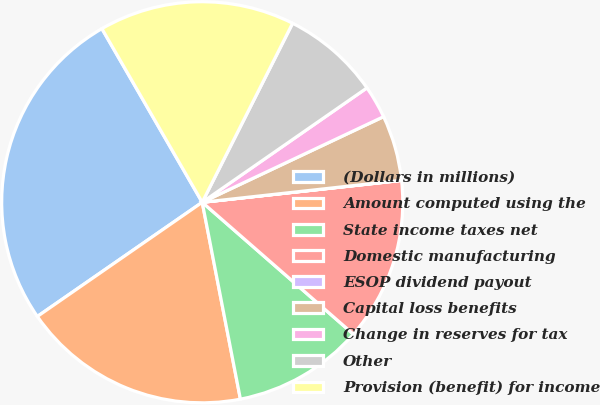Convert chart to OTSL. <chart><loc_0><loc_0><loc_500><loc_500><pie_chart><fcel>(Dollars in millions)<fcel>Amount computed using the<fcel>State income taxes net<fcel>Domestic manufacturing<fcel>ESOP dividend payout<fcel>Capital loss benefits<fcel>Change in reserves for tax<fcel>Other<fcel>Provision (benefit) for income<nl><fcel>26.3%<fcel>18.41%<fcel>10.53%<fcel>13.16%<fcel>0.01%<fcel>5.27%<fcel>2.64%<fcel>7.9%<fcel>15.78%<nl></chart> 